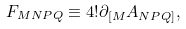<formula> <loc_0><loc_0><loc_500><loc_500>F _ { M N P Q } \equiv 4 ! \partial _ { [ M } A _ { N P Q ] } ,</formula> 